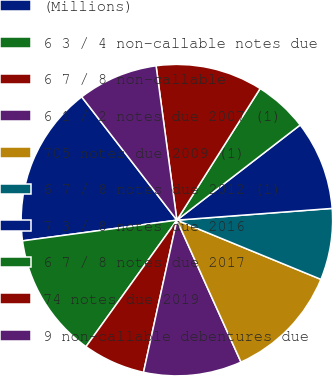<chart> <loc_0><loc_0><loc_500><loc_500><pie_chart><fcel>(Millions)<fcel>6 3 / 4 non-callable notes due<fcel>6 7 / 8 non-callable<fcel>6 1 / 2 notes due 2007 (1)<fcel>705 notes due 2009 (1)<fcel>6 7 / 8 notes due 2012 (1)<fcel>7 3 / 8 notes due 2016<fcel>6 7 / 8 notes due 2017<fcel>74 notes due 2019<fcel>9 non-callable debentures due<nl><fcel>16.66%<fcel>12.96%<fcel>6.48%<fcel>10.19%<fcel>12.04%<fcel>7.41%<fcel>9.26%<fcel>5.56%<fcel>11.11%<fcel>8.33%<nl></chart> 